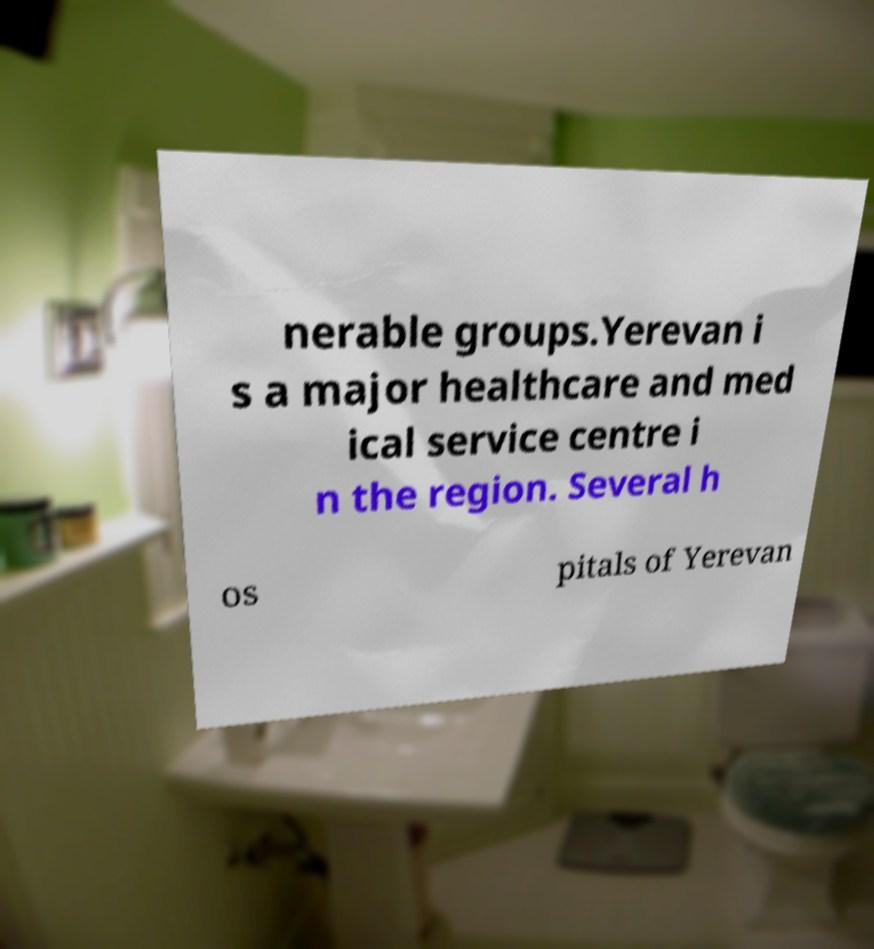Could you assist in decoding the text presented in this image and type it out clearly? nerable groups.Yerevan i s a major healthcare and med ical service centre i n the region. Several h os pitals of Yerevan 